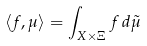<formula> <loc_0><loc_0><loc_500><loc_500>\langle f , \mu \rangle = \int _ { X { \times } \Xi } f \, d \tilde { \mu }</formula> 